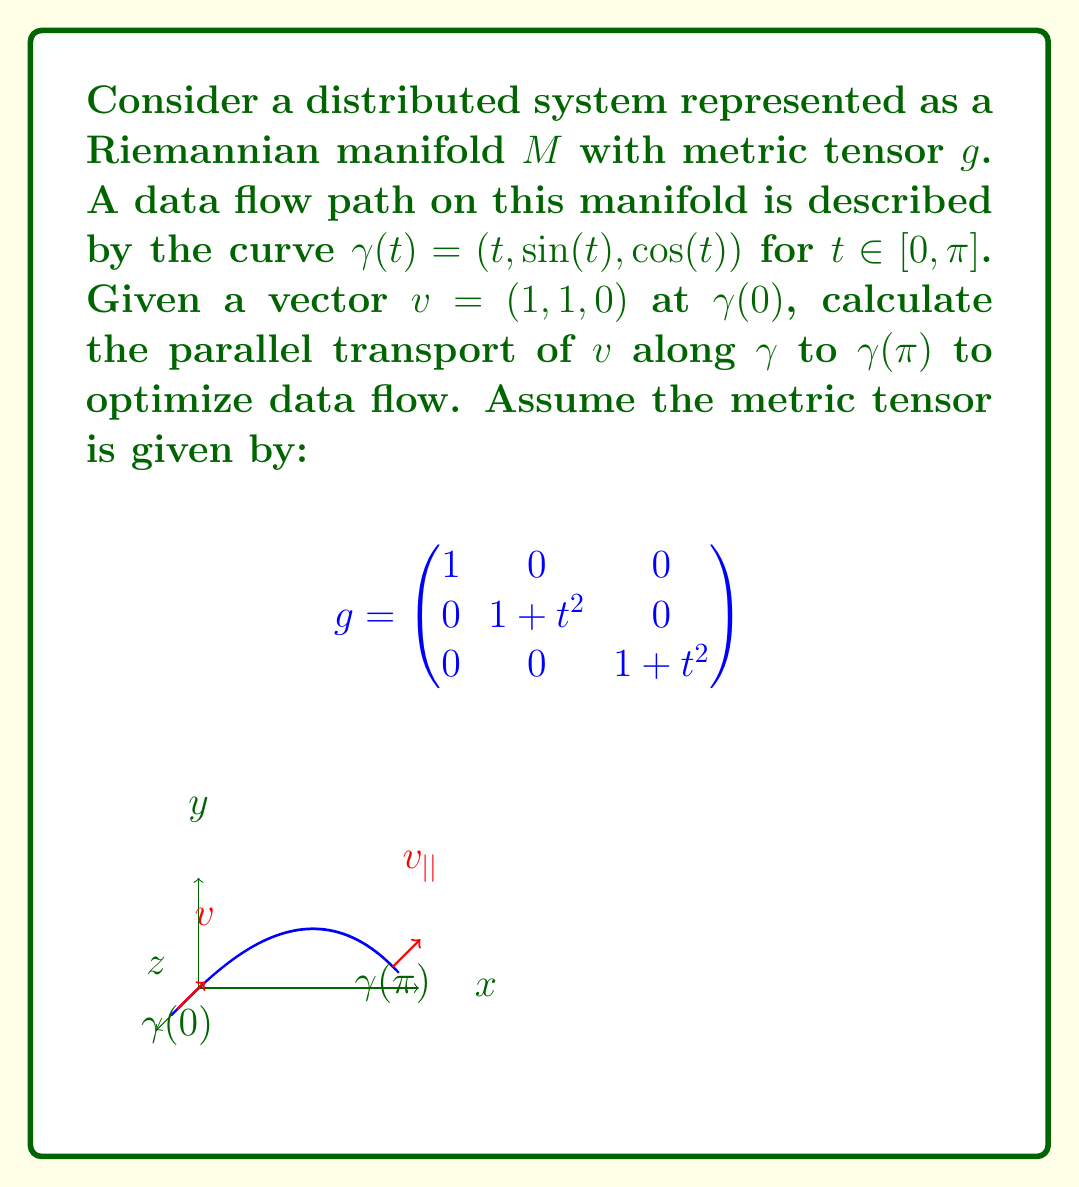Can you answer this question? To solve this problem, we'll follow these steps:

1) First, we need to calculate the Christoffel symbols for the given metric tensor. The Christoffel symbols are given by:

   $$\Gamma^k_{ij} = \frac{1}{2}g^{kl}(\partial_i g_{jl} + \partial_j g_{il} - \partial_l g_{ij})$$

2) For our metric, the non-zero Christoffel symbols are:

   $$\Gamma^2_{12} = \Gamma^2_{21} = \Gamma^3_{13} = \Gamma^3_{31} = \frac{t}{1+t^2}$$

3) The parallel transport equation is given by:

   $$\frac{dv^i}{dt} + \Gamma^i_{jk}\frac{d\gamma^j}{dt}v^k = 0$$

4) Substituting our curve $\gamma(t) = (t, \sin(t), \cos(t))$ and Christoffel symbols, we get:

   $$\frac{dv^1}{dt} = 0$$
   $$\frac{dv^2}{dt} + \frac{t}{1+t^2}v^2 = 0$$
   $$\frac{dv^3}{dt} + \frac{t}{1+t^2}v^3 = 0$$

5) Solving these differential equations:

   $v^1(t) = c_1$ (constant)
   $v^2(t) = \frac{c_2}{\sqrt{1+t^2}}$
   $v^3(t) = \frac{c_3}{\sqrt{1+t^2}}$

6) Using the initial condition $v(0) = (1, 1, 0)$, we get:

   $c_1 = 1$, $c_2 = 1$, $c_3 = 0$

7) Therefore, the parallel transport of $v$ along $\gamma$ is:

   $$v_{||}(t) = (1, \frac{1}{\sqrt{1+t^2}}, 0)$$

8) At $t = \pi$, the parallel transported vector is:

   $$v_{||}(\pi) = (1, \frac{1}{\sqrt{1+\pi^2}}, 0)$$
Answer: $(1, \frac{1}{\sqrt{1+\pi^2}}, 0)$ 